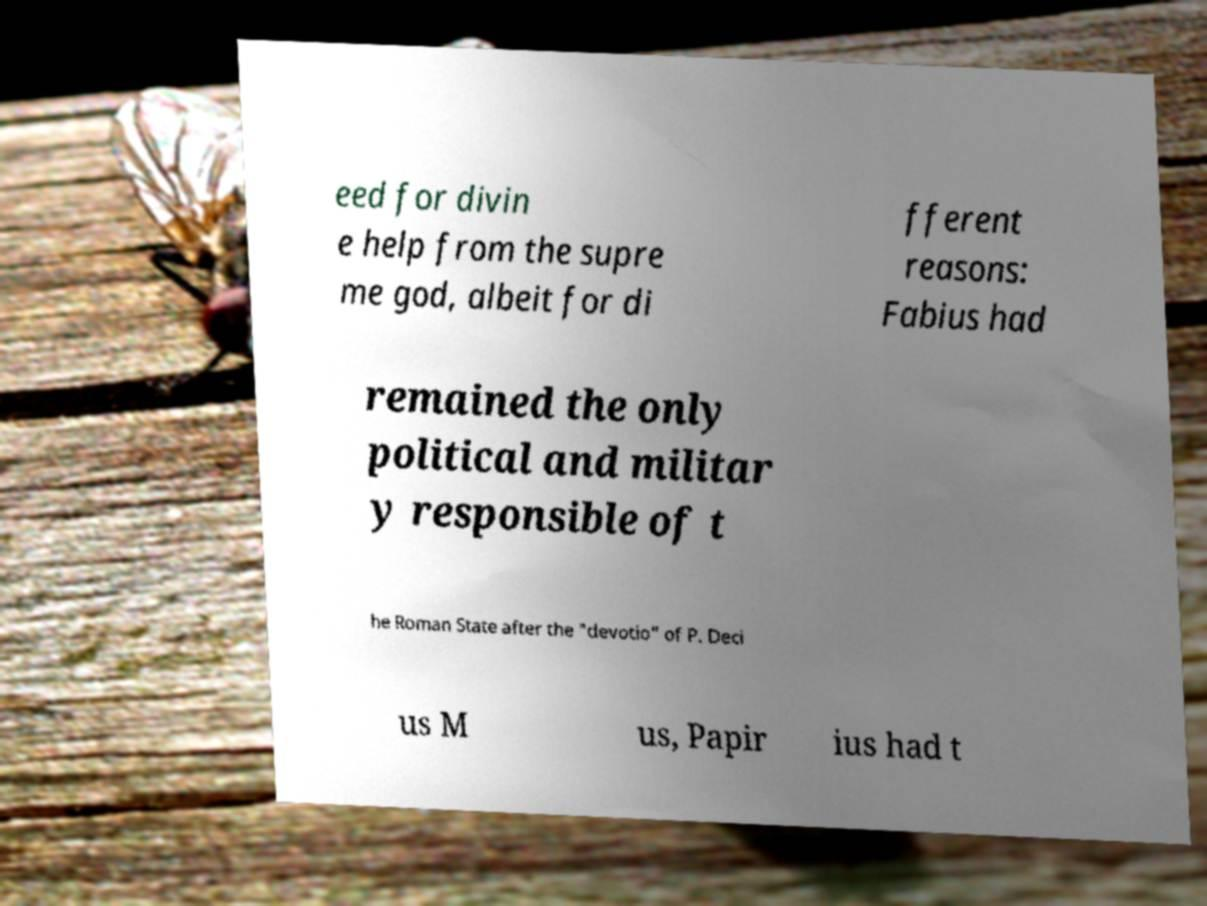Please identify and transcribe the text found in this image. eed for divin e help from the supre me god, albeit for di fferent reasons: Fabius had remained the only political and militar y responsible of t he Roman State after the "devotio" of P. Deci us M us, Papir ius had t 